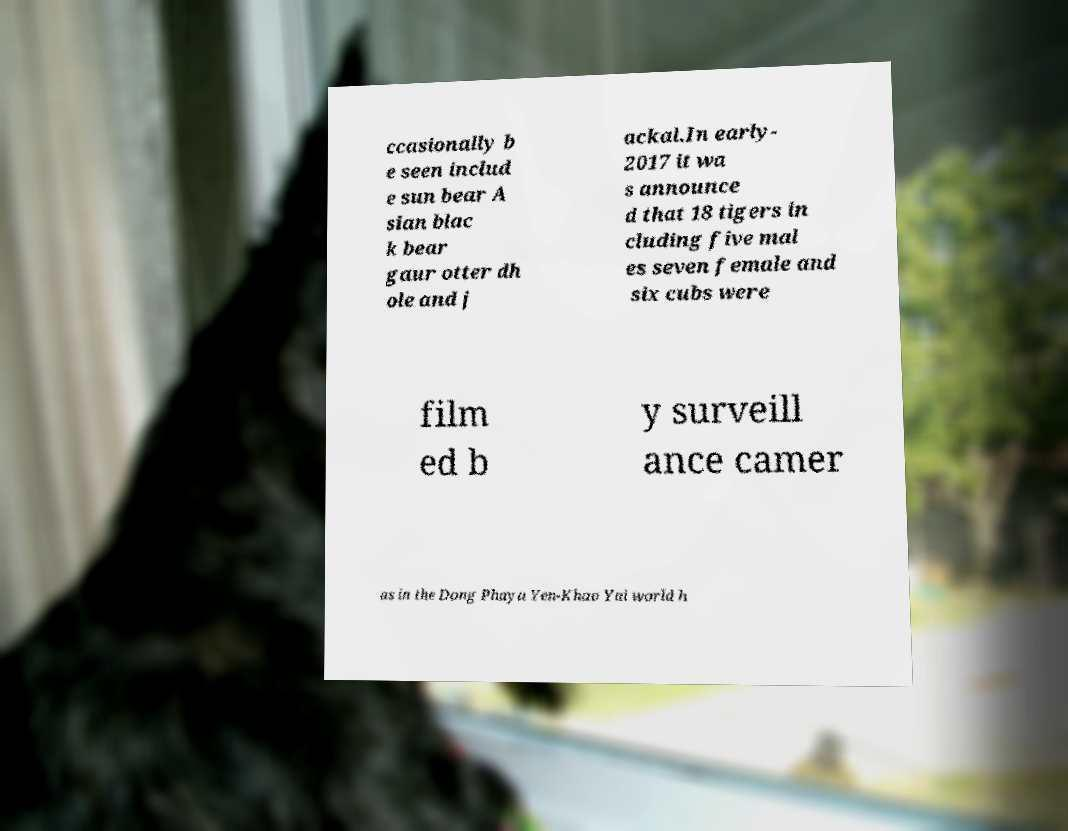Can you accurately transcribe the text from the provided image for me? ccasionally b e seen includ e sun bear A sian blac k bear gaur otter dh ole and j ackal.In early- 2017 it wa s announce d that 18 tigers in cluding five mal es seven female and six cubs were film ed b y surveill ance camer as in the Dong Phaya Yen-Khao Yai world h 